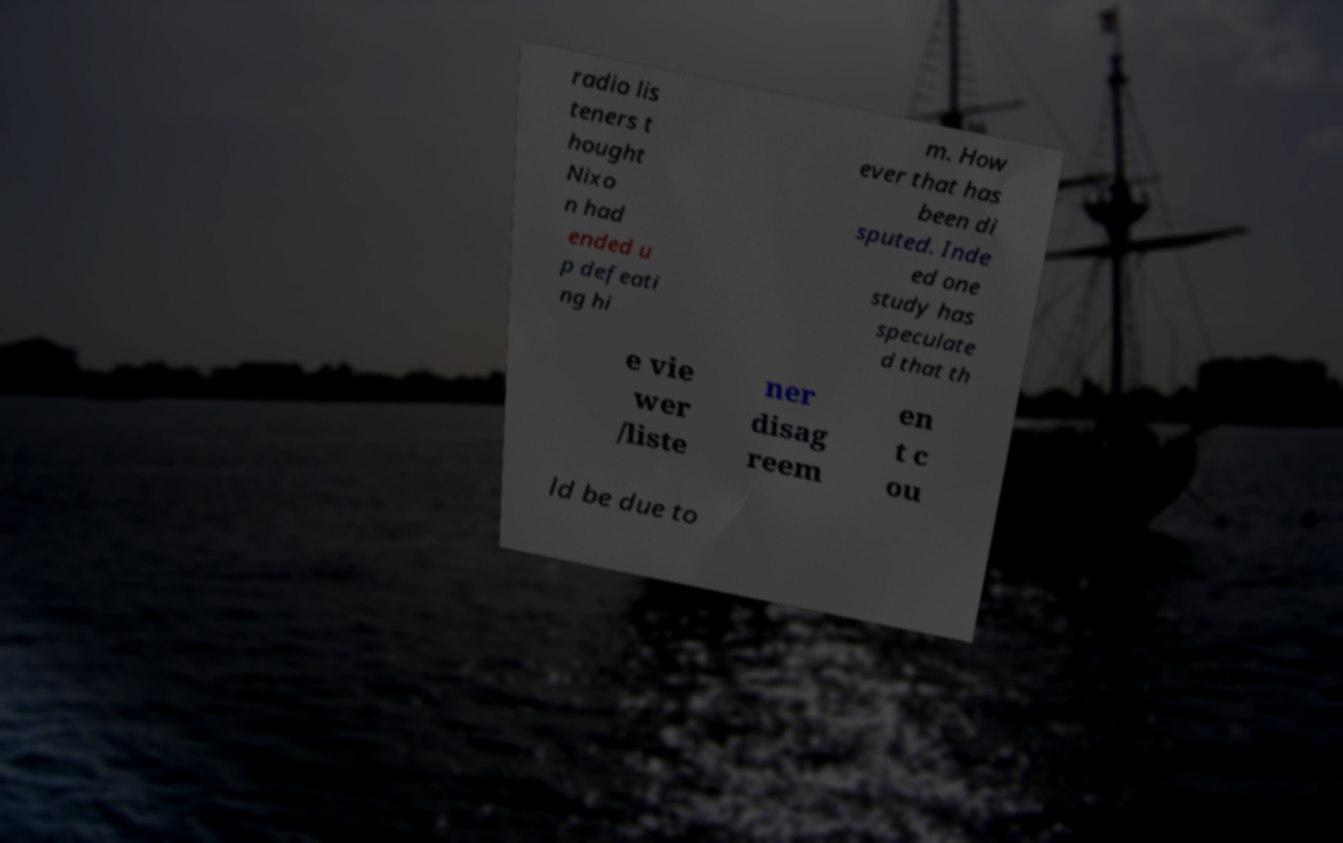Can you accurately transcribe the text from the provided image for me? radio lis teners t hought Nixo n had ended u p defeati ng hi m. How ever that has been di sputed. Inde ed one study has speculate d that th e vie wer /liste ner disag reem en t c ou ld be due to 